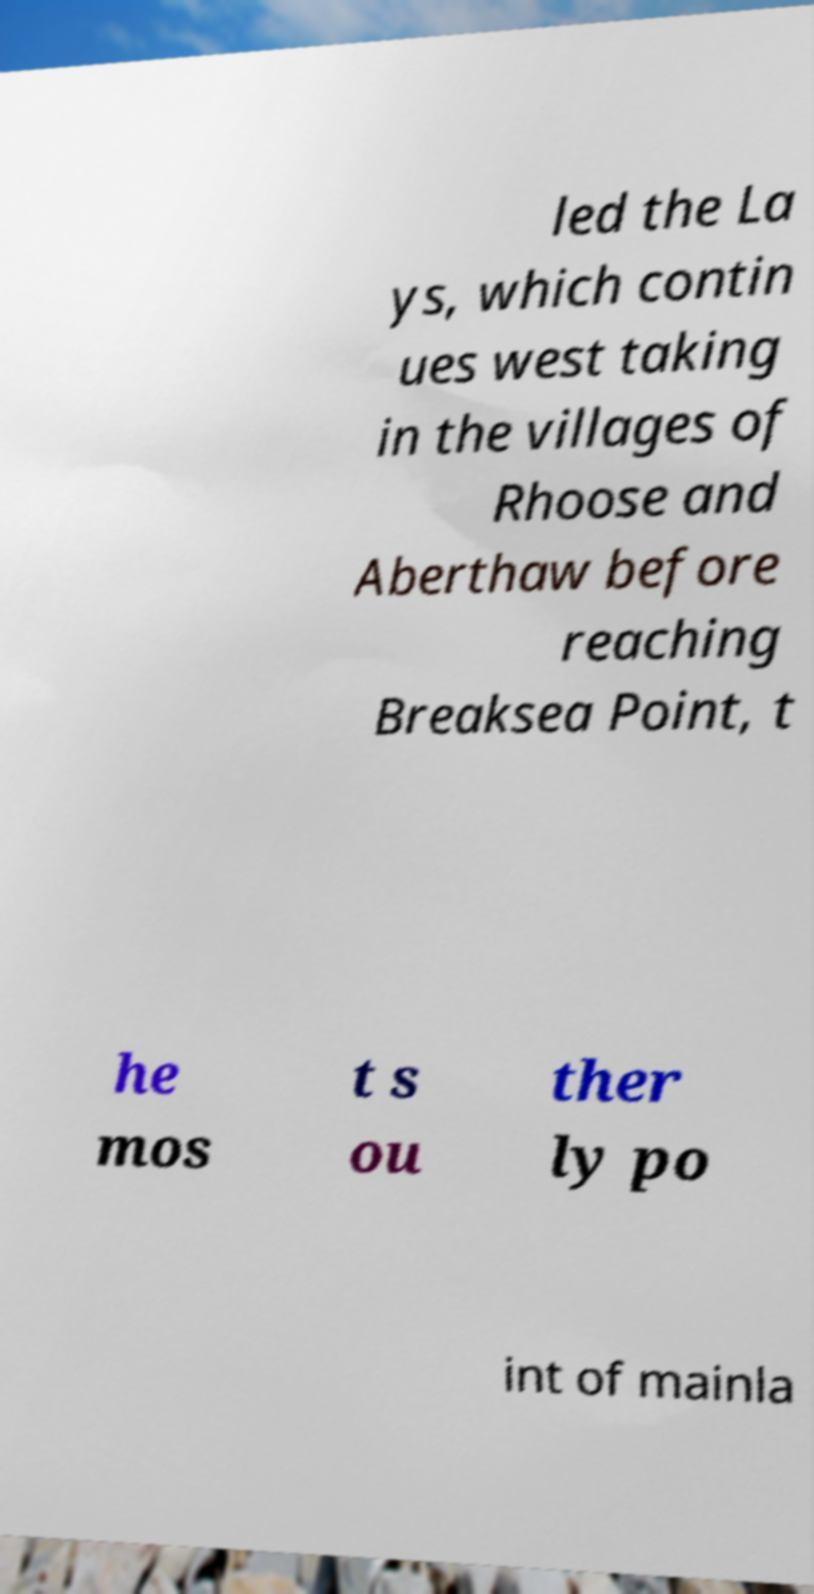I need the written content from this picture converted into text. Can you do that? led the La ys, which contin ues west taking in the villages of Rhoose and Aberthaw before reaching Breaksea Point, t he mos t s ou ther ly po int of mainla 